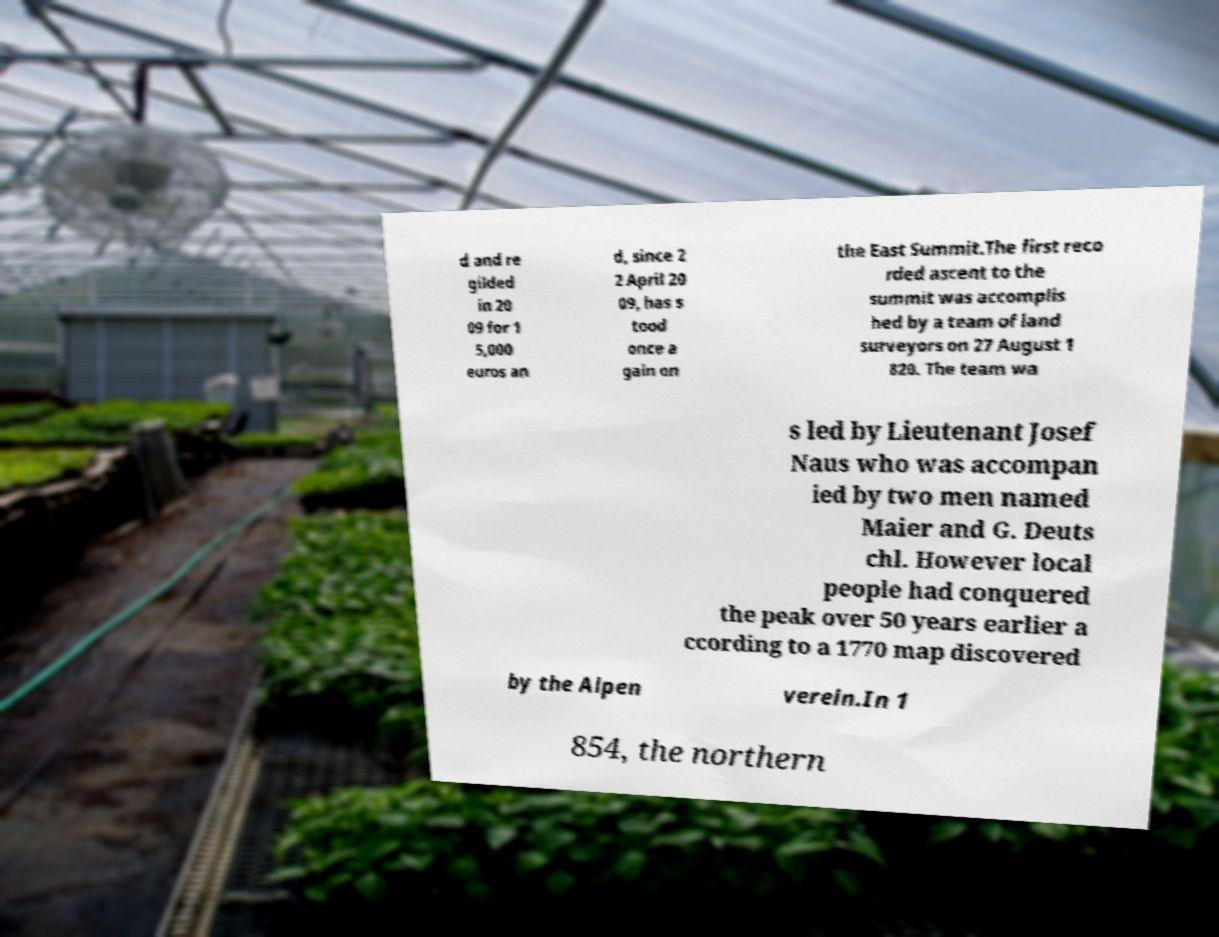Please read and relay the text visible in this image. What does it say? d and re gilded in 20 09 for 1 5,000 euros an d, since 2 2 April 20 09, has s tood once a gain on the East Summit.The first reco rded ascent to the summit was accomplis hed by a team of land surveyors on 27 August 1 820. The team wa s led by Lieutenant Josef Naus who was accompan ied by two men named Maier and G. Deuts chl. However local people had conquered the peak over 50 years earlier a ccording to a 1770 map discovered by the Alpen verein.In 1 854, the northern 